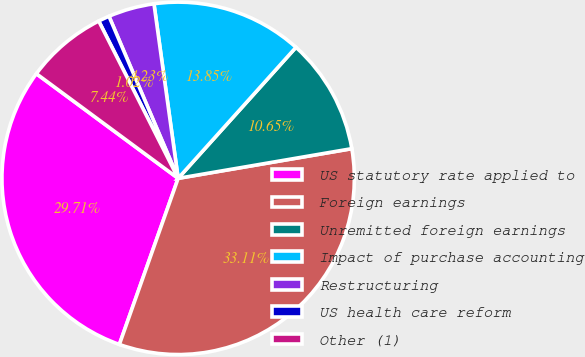Convert chart to OTSL. <chart><loc_0><loc_0><loc_500><loc_500><pie_chart><fcel>US statutory rate applied to<fcel>Foreign earnings<fcel>Unremitted foreign earnings<fcel>Impact of purchase accounting<fcel>Restructuring<fcel>US health care reform<fcel>Other (1)<nl><fcel>29.71%<fcel>33.11%<fcel>10.65%<fcel>13.85%<fcel>4.23%<fcel>1.02%<fcel>7.44%<nl></chart> 